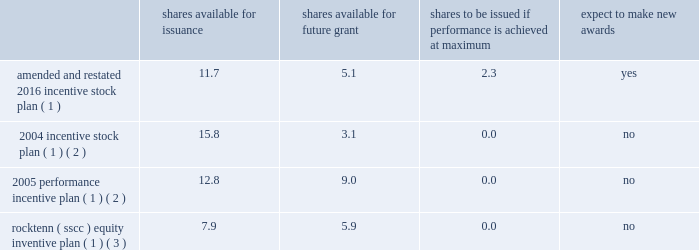Westrock company notes to consolidated financial statements 2014 ( continued ) note 20 .
Stockholders 2019 equity capitalization our capital stock consists solely of common stock .
Holders of our common stock are entitled to one vote per share .
Our amended and restated certificate of incorporation also authorizes preferred stock , of which no shares have been issued .
The terms and provisions of such shares will be determined by our board of directors upon any issuance of such shares in accordance with our certificate of incorporation .
Stock repurchase plan in july 2015 , our board of directors authorized a repurchase program of up to 40.0 million shares of our common stock , representing approximately 15% ( 15 % ) of our outstanding common stock as of july 1 , 2015 .
The shares of our common stock may be repurchased over an indefinite period of time at the discretion of management .
In fiscal 2019 , we repurchased approximately 2.1 million shares of our common stock for an aggregate cost of $ 88.6 million .
In fiscal 2018 , we repurchased approximately 3.4 million shares of our common stock for an aggregate cost of $ 195.1 million .
In fiscal 2017 , we repurchased approximately 1.8 million shares of our common stock for an aggregate cost of $ 93.0 million .
As of september 30 , 2019 , we had remaining authorization under the repurchase program authorized in july 2015 to purchase approximately 19.1 million shares of our common stock .
Note 21 .
Share-based compensation share-based compensation plans at our annual meeting of stockholders held on february 2 , 2016 , our stockholders approved the westrock company 2016 incentive stock plan .
The 2016 incentive stock plan was amended and restated on february 2 , 2018 ( the 201camended and restated 2016 incentive stock plan 201d ) .
The amended and restated 2016 incentive stock plan allows for the granting of options , restricted stock , sars and restricted stock units to certain key employees and directors .
The table below shows the approximate number of shares : available for issuance , available for future grant , to be issued if restricted awards granted with a performance condition recorded at target achieve the maximum award , and if new grants pursuant to the plan are expected to be issued , each as adjusted as necessary for corporate actions ( in millions ) .
Shares available issuance shares available for future shares to be issued if performance is achieved at maximum expect to awards amended and restated 2016 incentive stock plan ( 1 ) 11.7 5.1 2.3 yes 2004 incentive stock plan ( 1 ) ( 2 ) 15.8 3.1 0.0 no 2005 performance incentive plan ( 1 ) ( 2 ) 12.8 9.0 0.0 no rocktenn ( sscc ) equity inventive plan ( 1 ) ( 3 ) 7.9 5.9 0.0 no ( 1 ) as part of the separation , equity-based incentive awards were generally adjusted to maintain the intrinsic value of awards immediately prior to the separation .
The number of unvested restricted stock awards and unexercised stock options and sars at the time of the separation were increased by an exchange factor of approximately 1.12 .
In addition , the exercise price of unexercised stock options and sars at the time of the separation was converted to decrease the exercise price by an exchange factor of approximately 1.12 .
( 2 ) in connection with the combination , westrock assumed all rocktenn and mwv equity incentive plans .
We issued awards to certain key employees and our directors pursuant to our rocktenn 2004 incentive stock plan , as amended , and our mwv 2005 performance incentive plan , as amended .
The awards were converted into westrock awards using the conversion factor as described in the business combination agreement .
( 3 ) in connection with the smurfit-stone acquisition , we assumed the smurfit-stone equity incentive plan , which was renamed the rock-tenn company ( sscc ) equity incentive plan .
The awards were converted into shares of rocktenn common stock , options and restricted stock units , as applicable , using the conversion factor as described in the merger agreement. .
Westrock company notes to consolidated financial statements 2014 ( continued ) note 20 .
Stockholders 2019 equity capitalization our capital stock consists solely of common stock .
Holders of our common stock are entitled to one vote per share .
Our amended and restated certificate of incorporation also authorizes preferred stock , of which no shares have been issued .
The terms and provisions of such shares will be determined by our board of directors upon any issuance of such shares in accordance with our certificate of incorporation .
Stock repurchase plan in july 2015 , our board of directors authorized a repurchase program of up to 40.0 million shares of our common stock , representing approximately 15% ( 15 % ) of our outstanding common stock as of july 1 , 2015 .
The shares of our common stock may be repurchased over an indefinite period of time at the discretion of management .
In fiscal 2019 , we repurchased approximately 2.1 million shares of our common stock for an aggregate cost of $ 88.6 million .
In fiscal 2018 , we repurchased approximately 3.4 million shares of our common stock for an aggregate cost of $ 195.1 million .
In fiscal 2017 , we repurchased approximately 1.8 million shares of our common stock for an aggregate cost of $ 93.0 million .
As of september 30 , 2019 , we had remaining authorization under the repurchase program authorized in july 2015 to purchase approximately 19.1 million shares of our common stock .
Note 21 .
Share-based compensation share-based compensation plans at our annual meeting of stockholders held on february 2 , 2016 , our stockholders approved the westrock company 2016 incentive stock plan .
The 2016 incentive stock plan was amended and restated on february 2 , 2018 ( the 201camended and restated 2016 incentive stock plan 201d ) .
The amended and restated 2016 incentive stock plan allows for the granting of options , restricted stock , sars and restricted stock units to certain key employees and directors .
The table below shows the approximate number of shares : available for issuance , available for future grant , to be issued if restricted awards granted with a performance condition recorded at target achieve the maximum award , and if new grants pursuant to the plan are expected to be issued , each as adjusted as necessary for corporate actions ( in millions ) .
Shares available issuance shares available for future shares to be issued if performance is achieved at maximum expect to awards amended and restated 2016 incentive stock plan ( 1 ) 11.7 5.1 2.3 yes 2004 incentive stock plan ( 1 ) ( 2 ) 15.8 3.1 0.0 no 2005 performance incentive plan ( 1 ) ( 2 ) 12.8 9.0 0.0 no rocktenn ( sscc ) equity inventive plan ( 1 ) ( 3 ) 7.9 5.9 0.0 no ( 1 ) as part of the separation , equity-based incentive awards were generally adjusted to maintain the intrinsic value of awards immediately prior to the separation .
The number of unvested restricted stock awards and unexercised stock options and sars at the time of the separation were increased by an exchange factor of approximately 1.12 .
In addition , the exercise price of unexercised stock options and sars at the time of the separation was converted to decrease the exercise price by an exchange factor of approximately 1.12 .
( 2 ) in connection with the combination , westrock assumed all rocktenn and mwv equity incentive plans .
We issued awards to certain key employees and our directors pursuant to our rocktenn 2004 incentive stock plan , as amended , and our mwv 2005 performance incentive plan , as amended .
The awards were converted into westrock awards using the conversion factor as described in the business combination agreement .
( 3 ) in connection with the smurfit-stone acquisition , we assumed the smurfit-stone equity incentive plan , which was renamed the rock-tenn company ( sscc ) equity incentive plan .
The awards were converted into shares of rocktenn common stock , options and restricted stock units , as applicable , using the conversion factor as described in the merger agreement. .
What was the weighted average total of the aggregate cost of the per share repurchased from 2017 to 2019? 
Computations: (((88.6 + 195.1) + 93.0) / ((3.4 + 2.1) + 1.8))
Answer: 51.60274. 